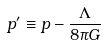<formula> <loc_0><loc_0><loc_500><loc_500>p ^ { \prime } \equiv p - { \frac { \Lambda } { 8 \pi G } }</formula> 